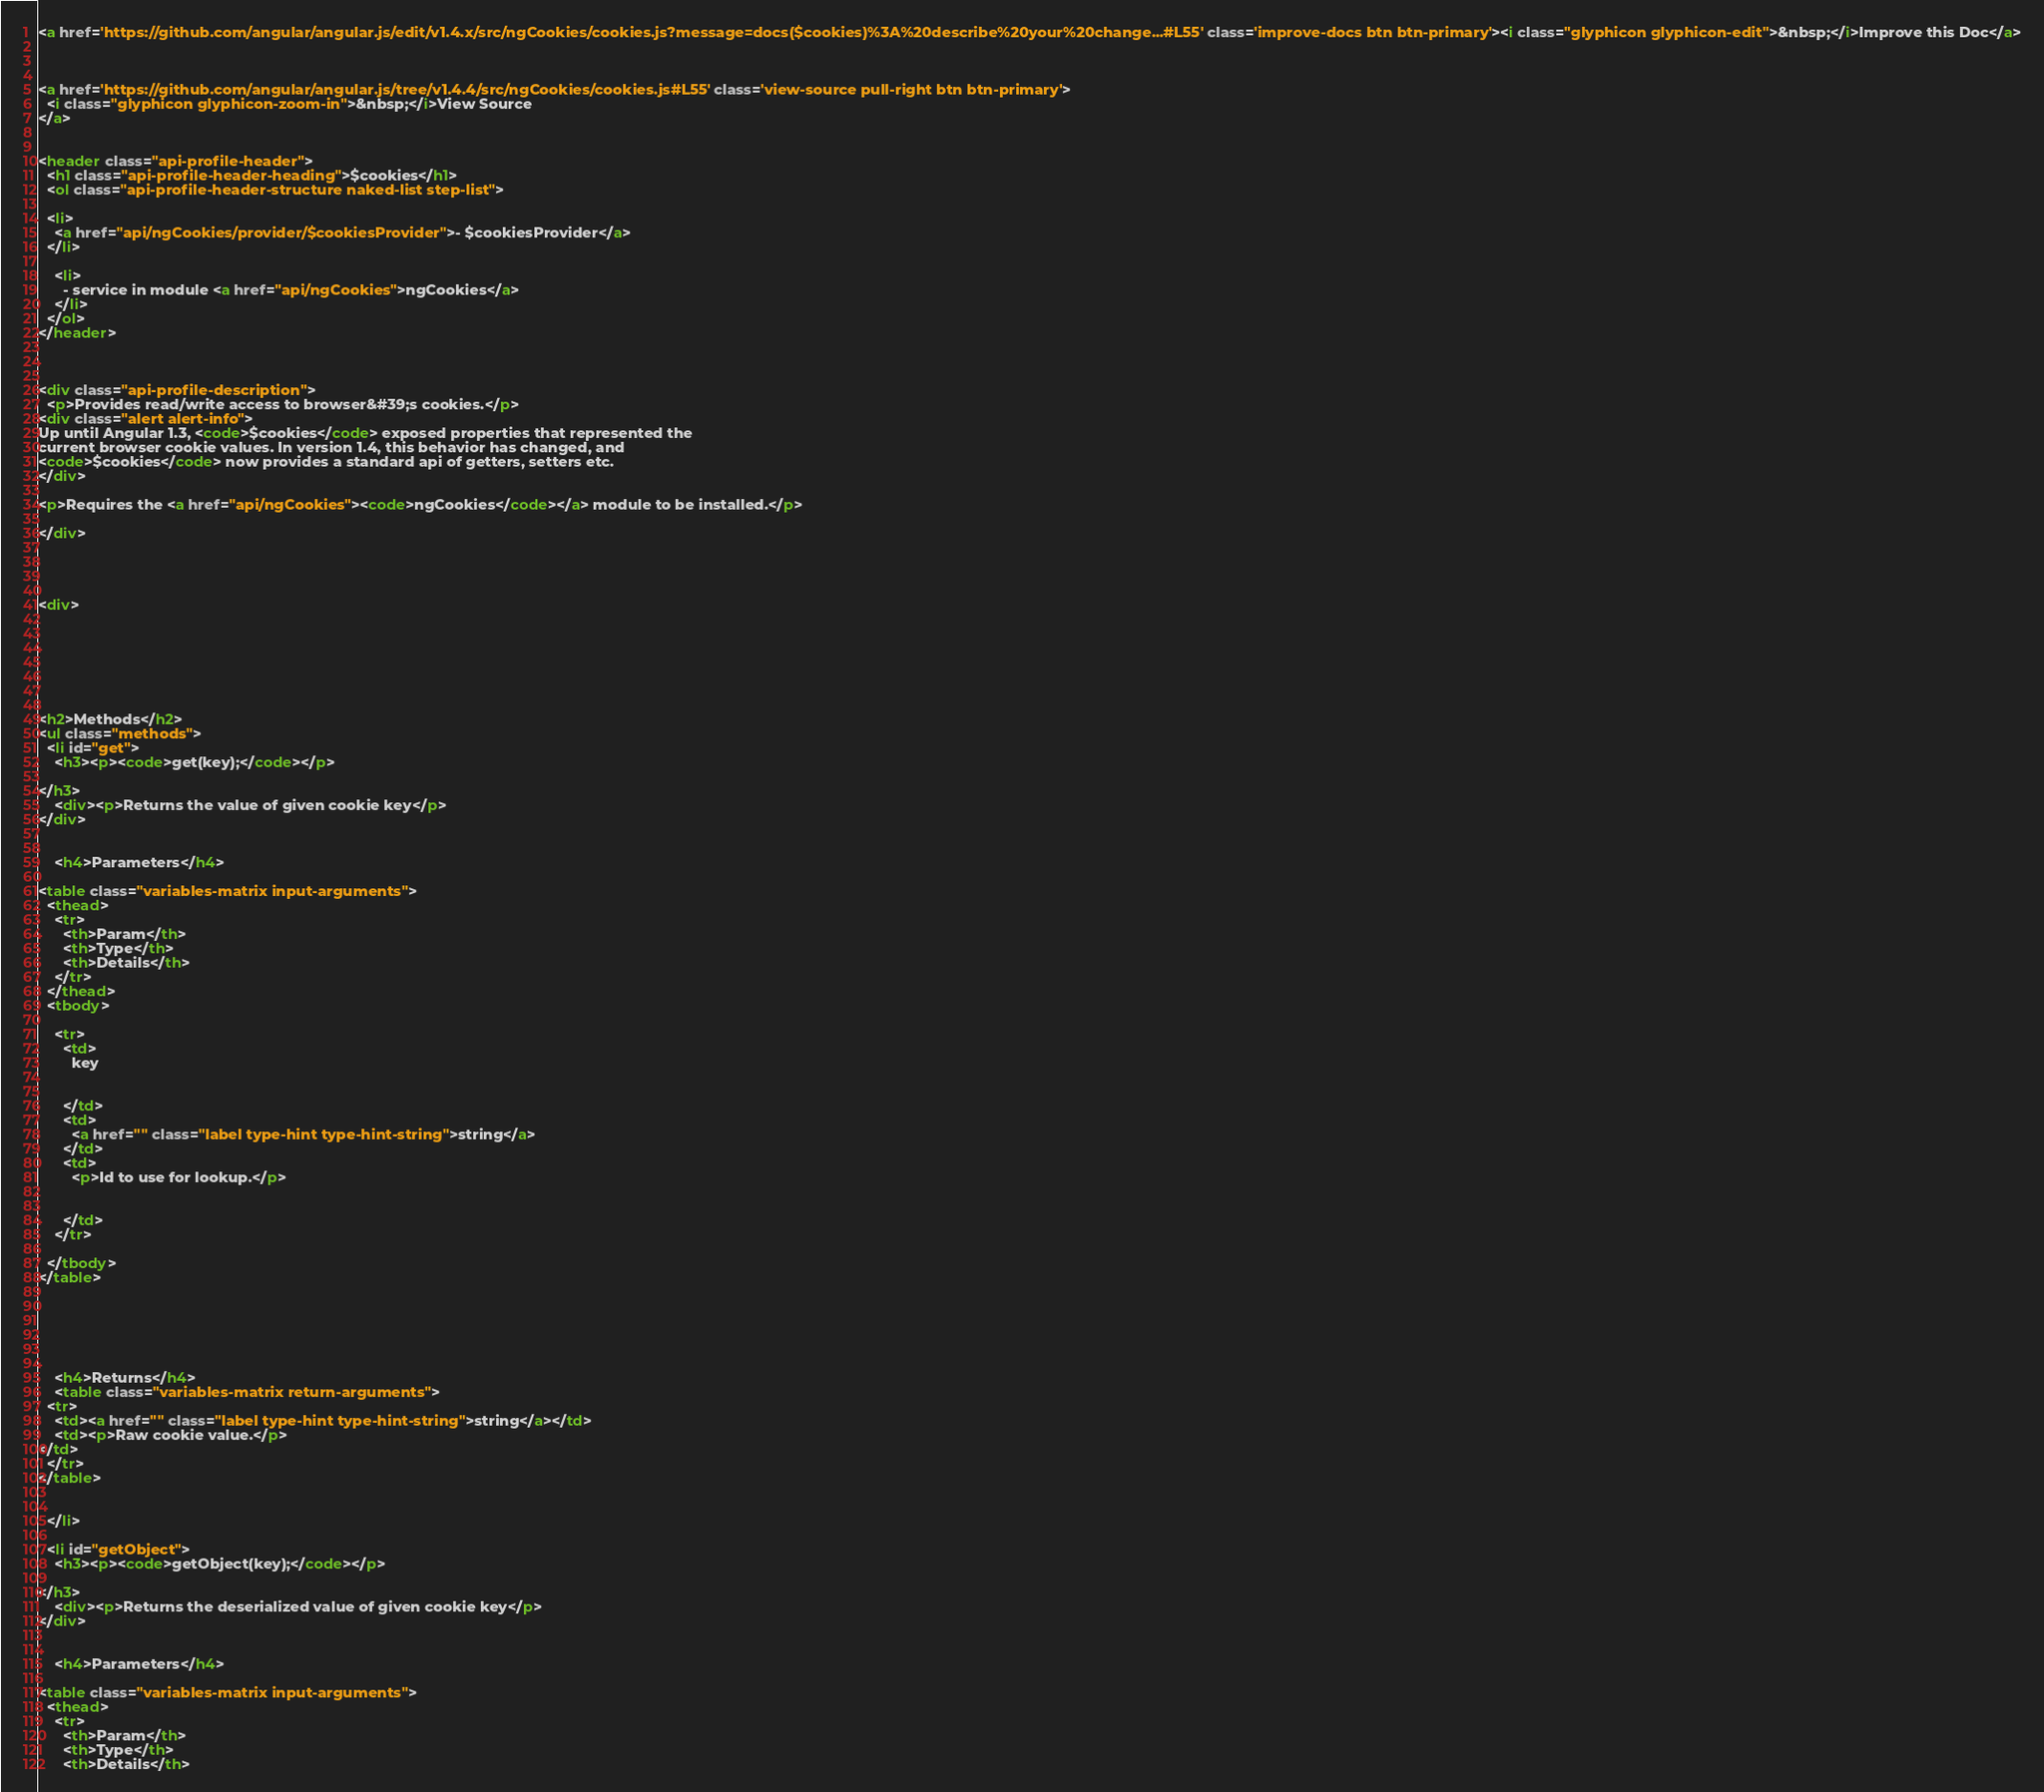<code> <loc_0><loc_0><loc_500><loc_500><_HTML_><a href='https://github.com/angular/angular.js/edit/v1.4.x/src/ngCookies/cookies.js?message=docs($cookies)%3A%20describe%20your%20change...#L55' class='improve-docs btn btn-primary'><i class="glyphicon glyphicon-edit">&nbsp;</i>Improve this Doc</a>



<a href='https://github.com/angular/angular.js/tree/v1.4.4/src/ngCookies/cookies.js#L55' class='view-source pull-right btn btn-primary'>
  <i class="glyphicon glyphicon-zoom-in">&nbsp;</i>View Source
</a>


<header class="api-profile-header">
  <h1 class="api-profile-header-heading">$cookies</h1>
  <ol class="api-profile-header-structure naked-list step-list">
    
  <li>
    <a href="api/ngCookies/provider/$cookiesProvider">- $cookiesProvider</a>
  </li>

    <li>
      - service in module <a href="api/ngCookies">ngCookies</a>
    </li>
  </ol>
</header>



<div class="api-profile-description">
  <p>Provides read/write access to browser&#39;s cookies.</p>
<div class="alert alert-info">
Up until Angular 1.3, <code>$cookies</code> exposed properties that represented the
current browser cookie values. In version 1.4, this behavior has changed, and
<code>$cookies</code> now provides a standard api of getters, setters etc.
</div>

<p>Requires the <a href="api/ngCookies"><code>ngCookies</code></a> module to be installed.</p>

</div>




<div>
  

    

  

  
<h2>Methods</h2>
<ul class="methods">
  <li id="get">
    <h3><p><code>get(key);</code></p>

</h3>
    <div><p>Returns the value of given cookie key</p>
</div>

    
    <h4>Parameters</h4>
    
<table class="variables-matrix input-arguments">
  <thead>
    <tr>
      <th>Param</th>
      <th>Type</th>
      <th>Details</th>
    </tr>
  </thead>
  <tbody>
    
    <tr>
      <td>
        key
        
        
      </td>
      <td>
        <a href="" class="label type-hint type-hint-string">string</a>
      </td>
      <td>
        <p>Id to use for lookup.</p>

        
      </td>
    </tr>
    
  </tbody>
</table>

    

    
    
    
    <h4>Returns</h4>
    <table class="variables-matrix return-arguments">
  <tr>
    <td><a href="" class="label type-hint type-hint-string">string</a></td>
    <td><p>Raw cookie value.</p>
</td>
  </tr>
</table>
    

  </li>
  
  <li id="getObject">
    <h3><p><code>getObject(key);</code></p>

</h3>
    <div><p>Returns the deserialized value of given cookie key</p>
</div>

    
    <h4>Parameters</h4>
    
<table class="variables-matrix input-arguments">
  <thead>
    <tr>
      <th>Param</th>
      <th>Type</th>
      <th>Details</th></code> 